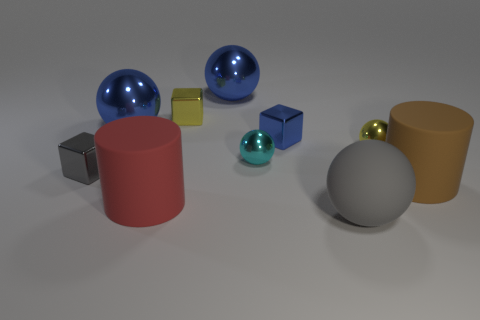There is a yellow shiny thing that is the same shape as the gray rubber thing; what size is it?
Offer a very short reply. Small. Are there the same number of yellow metal objects that are to the right of the small blue cube and small cubes on the right side of the big red cylinder?
Your answer should be very brief. No. What is the size of the yellow thing to the left of the blue cube?
Your answer should be very brief. Small. Are there an equal number of big gray matte balls that are behind the small blue thing and big green matte balls?
Keep it short and to the point. Yes. Are there any small cyan metallic things on the right side of the yellow sphere?
Provide a succinct answer. No. There is a tiny cyan shiny object; is it the same shape as the gray object right of the small gray metallic cube?
Provide a succinct answer. Yes. What is the color of the large ball that is the same material as the red thing?
Give a very brief answer. Gray. The big rubber sphere is what color?
Your answer should be compact. Gray. Are the cyan thing and the large cylinder that is behind the red cylinder made of the same material?
Your answer should be very brief. No. How many rubber cylinders are both in front of the brown rubber cylinder and right of the matte sphere?
Offer a terse response. 0. 